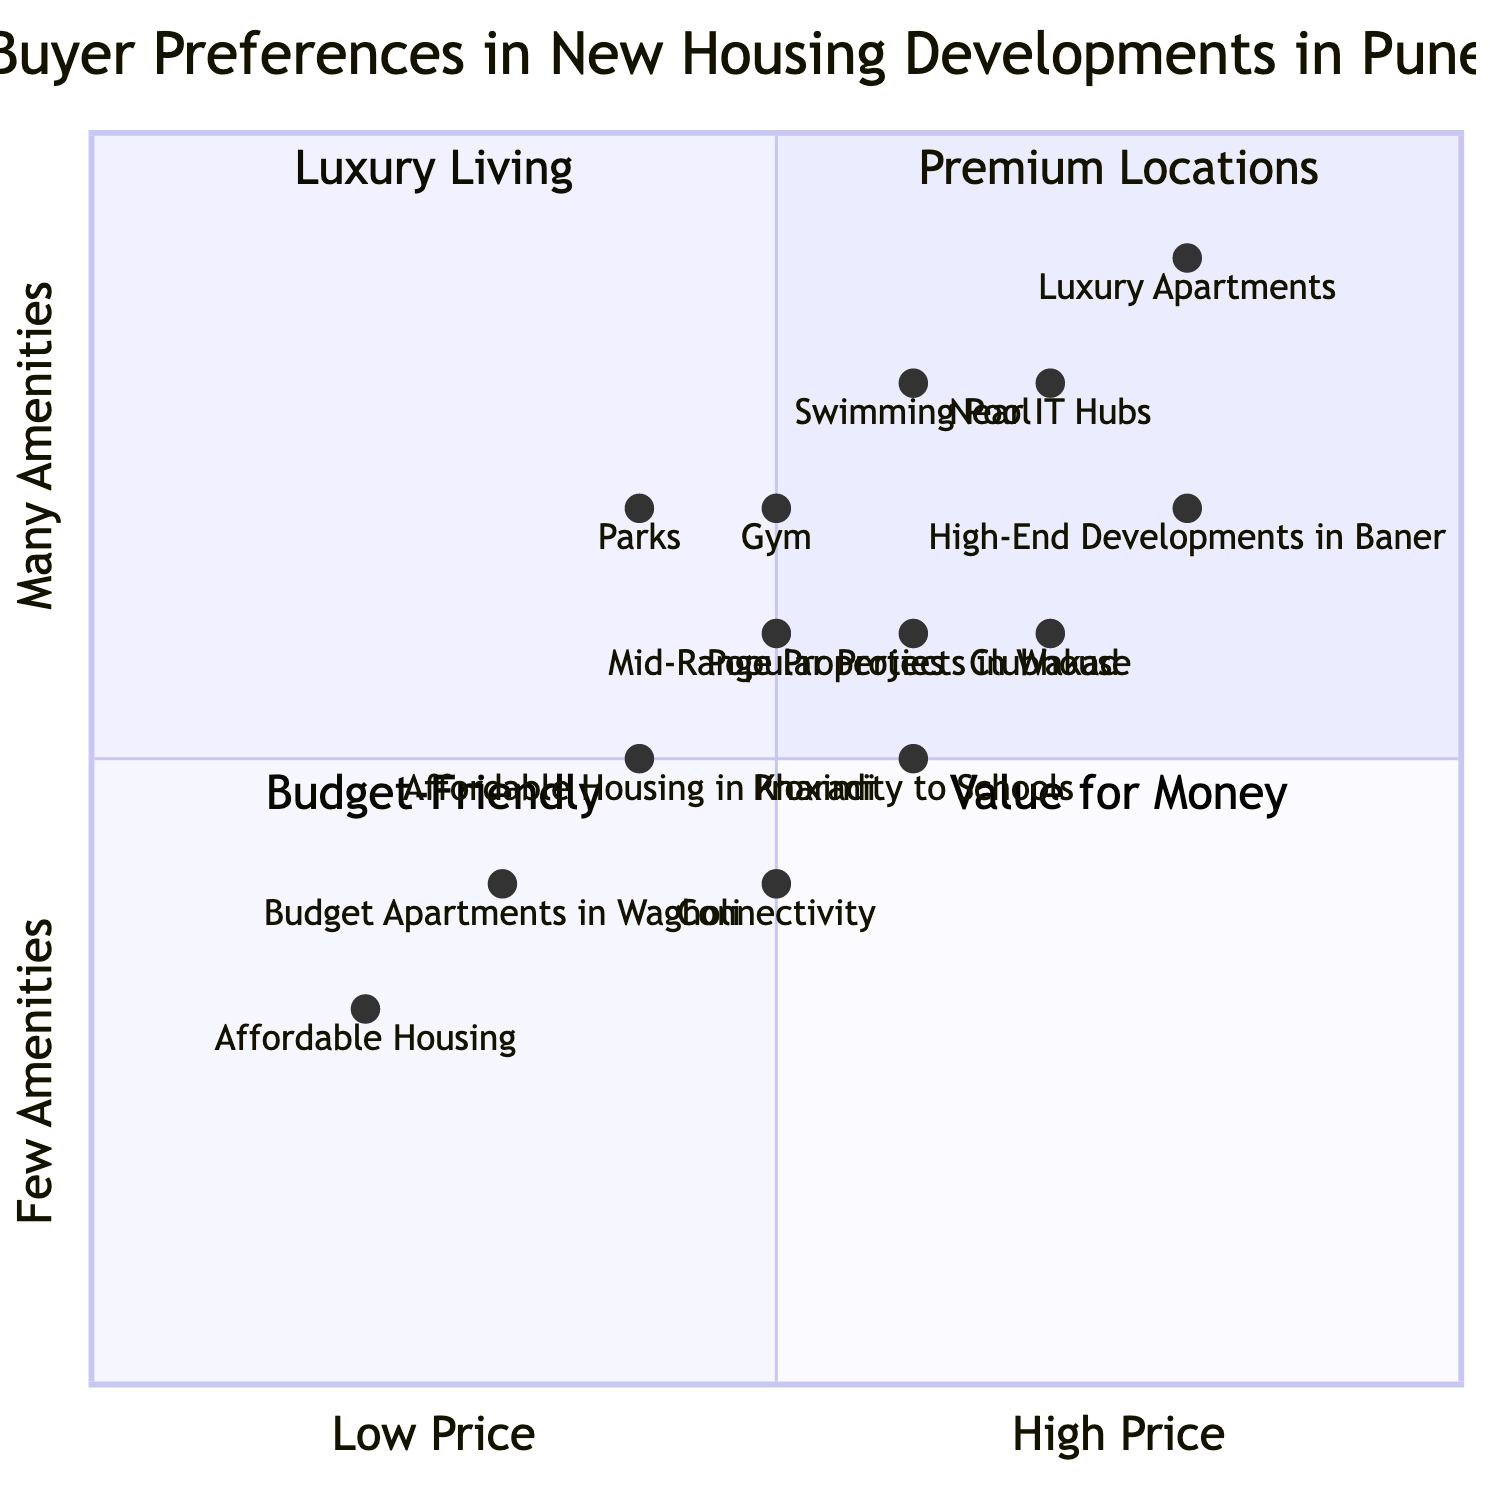What is the approximate price point of luxury apartments? The luxury apartments are located at the coordinates [0.8, 0.9] in the quadrant chart, representing a high price and many amenities. Therefore, the approximate price point can be inferred from their position as high.
Answer: High How many properties are categorized under value for money? In the value for money quadrant (quadrant 4), there is only one listed property, which is the popular projects in Wakad located at [0.6, 0.6].
Answer: One Which property has the highest amenities score? The luxury apartments are positioned at [0.8, 0.9], which indicates they have the highest score for amenities in the diagram.
Answer: Luxury Apartments What is the common feature between affordable housing in Kharadi and budget apartments in Wagholi? Both properties are located in a lower price range and cater to budget-conscious buyers, as they are positioned in the budget-friendly sections of the quadrant chart, suggesting affordability.
Answer: Affordability What is the location-based factor that has the greatest influence on buyer preferences in the diagram? The diagram indicates that proximity to IT hubs is a significant factor, with its placement at [0.7, 0.8]. This high score suggests that it is a prime consideration for buyers.
Answer: Proximity to IT Hubs Which quadrant contains properties that are classified as budget-friendly? The budget-friendly properties fall within quadrant 3 of the diagram, where the coordinates reflect lower price and lower amenities.
Answer: Quadrant 3 What is the importance of the gym compared to parks in the diagram? The gym has a score of [0.5, 0.7], while parks have a score of [0.4, 0.7]. This indicates that gym facilities score similarly in terms of amenities but may matter slightly more on the price scale than parks.
Answer: Higher Importance Which type of development is more focused on location rather than amenities in the diagram? The budget apartments in Wagholi are positioned at [0.3, 0.4], showing emphasis on lower price rather than amenities, making it clear that they focus on affordable location.
Answer: Budget Apartments in Wagholi 